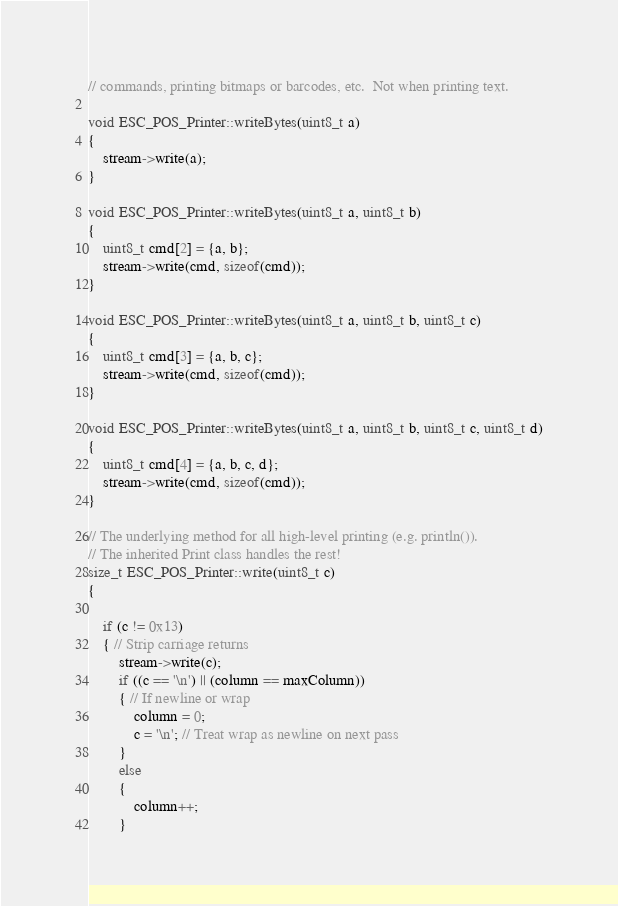<code> <loc_0><loc_0><loc_500><loc_500><_C++_>// commands, printing bitmaps or barcodes, etc.  Not when printing text.

void ESC_POS_Printer::writeBytes(uint8_t a)
{
    stream->write(a);
}

void ESC_POS_Printer::writeBytes(uint8_t a, uint8_t b)
{
    uint8_t cmd[2] = {a, b};
    stream->write(cmd, sizeof(cmd));
}

void ESC_POS_Printer::writeBytes(uint8_t a, uint8_t b, uint8_t c)
{
    uint8_t cmd[3] = {a, b, c};
    stream->write(cmd, sizeof(cmd));
}

void ESC_POS_Printer::writeBytes(uint8_t a, uint8_t b, uint8_t c, uint8_t d)
{
    uint8_t cmd[4] = {a, b, c, d};
    stream->write(cmd, sizeof(cmd));
}

// The underlying method for all high-level printing (e.g. println()).
// The inherited Print class handles the rest!
size_t ESC_POS_Printer::write(uint8_t c)
{

    if (c != 0x13)
    { // Strip carriage returns
        stream->write(c);
        if ((c == '\n') || (column == maxColumn))
        { // If newline or wrap
            column = 0;
            c = '\n'; // Treat wrap as newline on next pass
        }
        else
        {
            column++;
        }</code> 